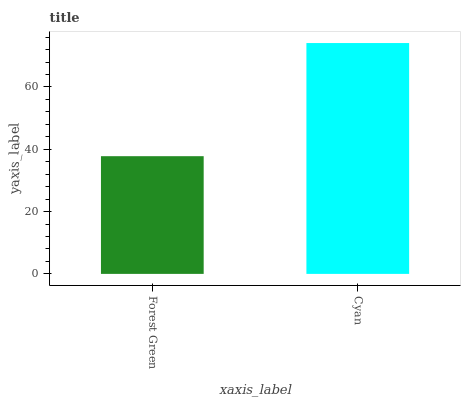Is Forest Green the minimum?
Answer yes or no. Yes. Is Cyan the maximum?
Answer yes or no. Yes. Is Cyan the minimum?
Answer yes or no. No. Is Cyan greater than Forest Green?
Answer yes or no. Yes. Is Forest Green less than Cyan?
Answer yes or no. Yes. Is Forest Green greater than Cyan?
Answer yes or no. No. Is Cyan less than Forest Green?
Answer yes or no. No. Is Cyan the high median?
Answer yes or no. Yes. Is Forest Green the low median?
Answer yes or no. Yes. Is Forest Green the high median?
Answer yes or no. No. Is Cyan the low median?
Answer yes or no. No. 